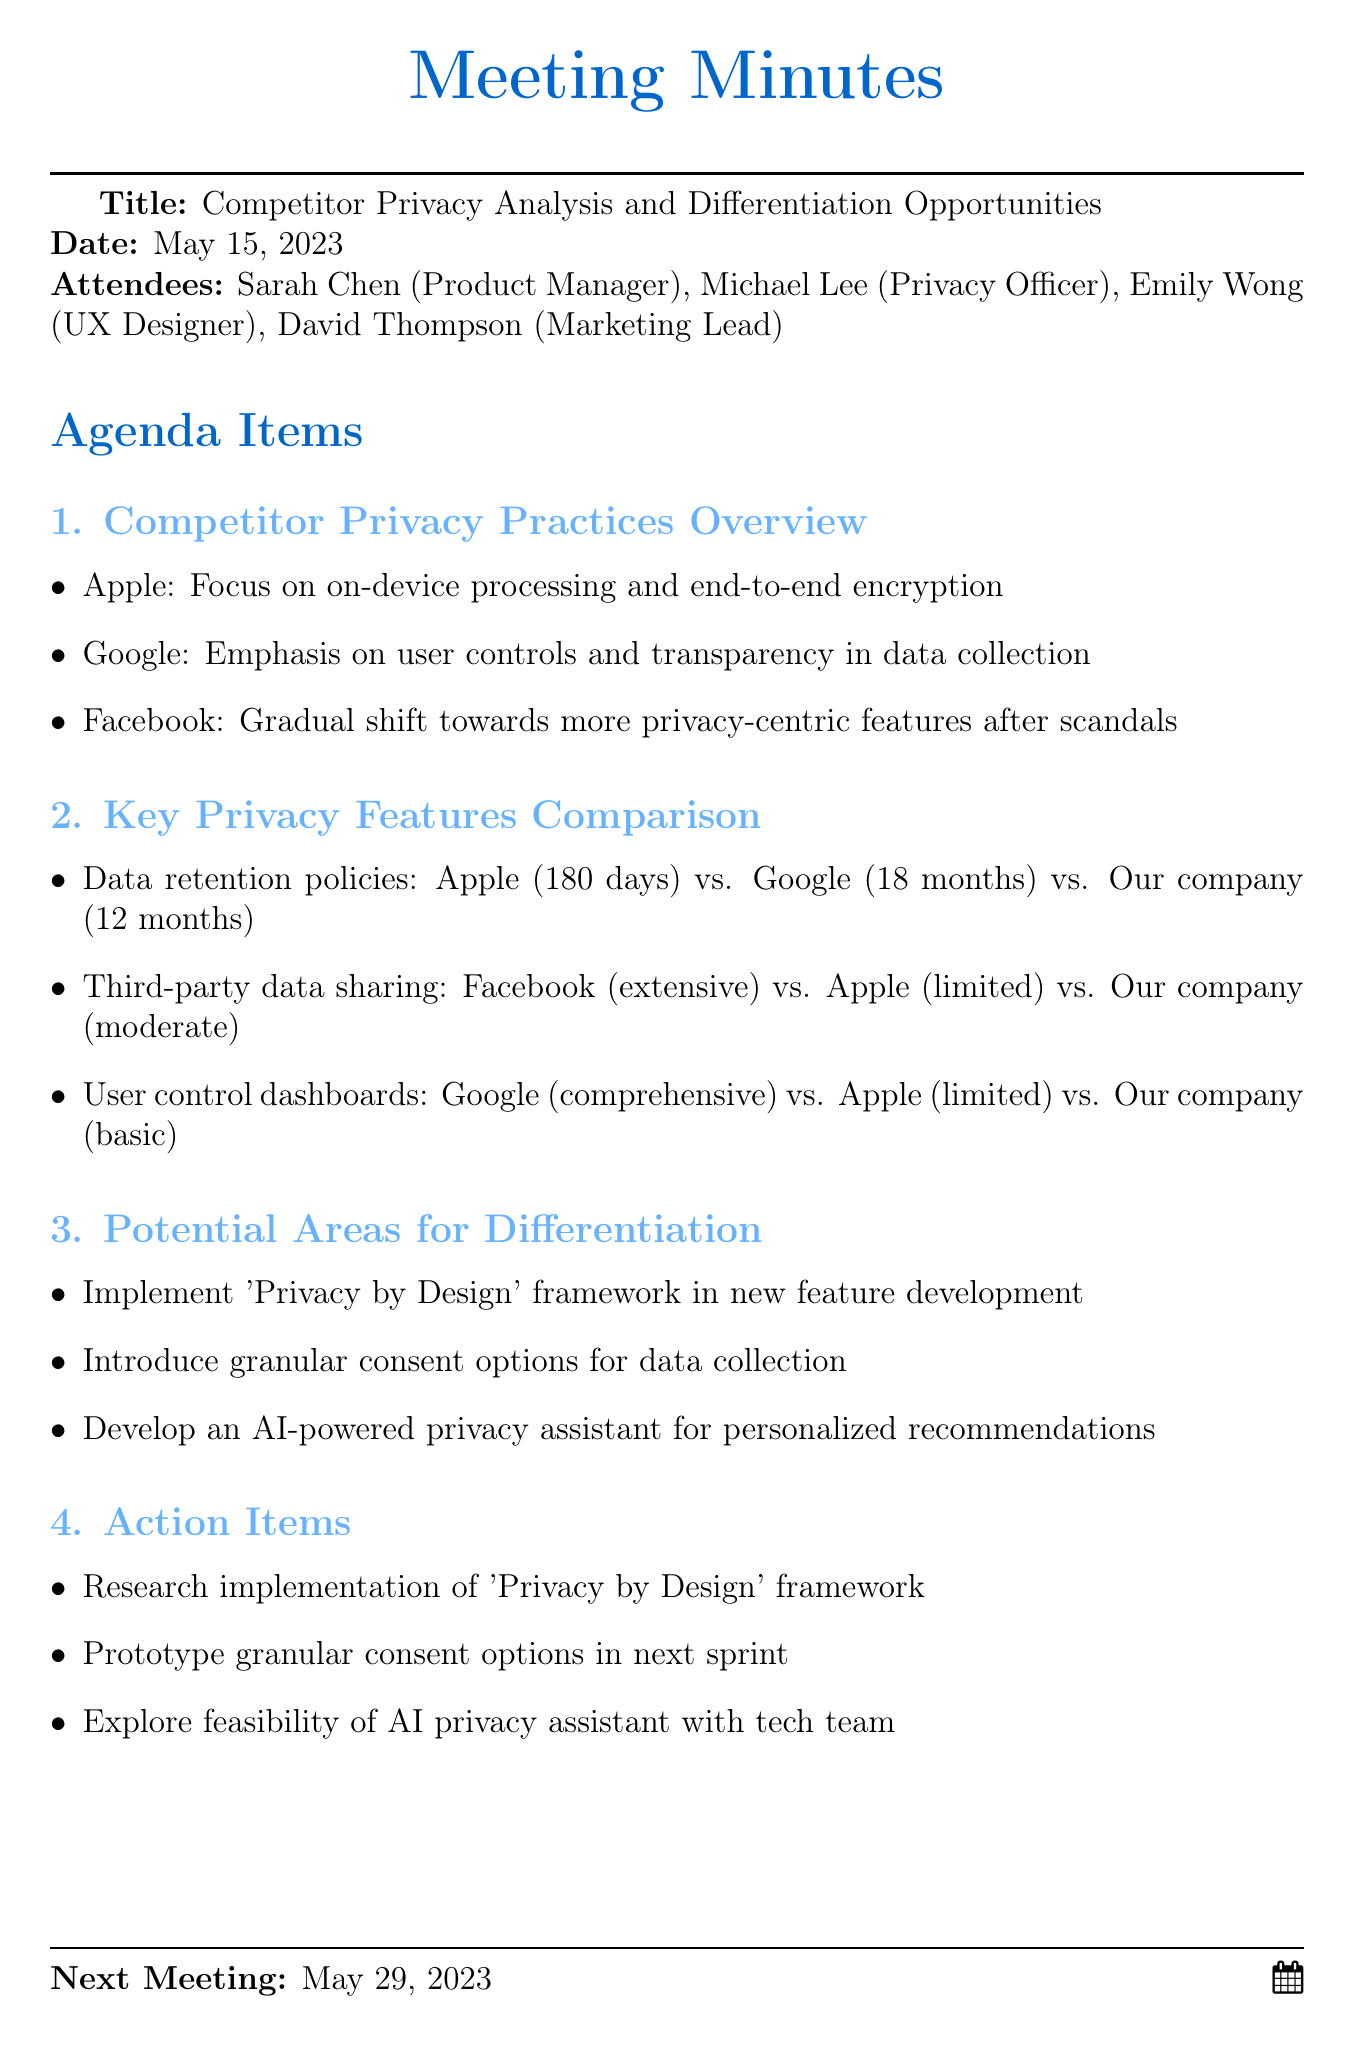What is the meeting date? The meeting took place on May 15, 2023, as stated at the top of the document.
Answer: May 15, 2023 Who is the Privacy Officer? The document specifies that Michael Lee holds the position of Privacy Officer among the attendees.
Answer: Michael Lee What is the data retention policy of our company? The comparison of data retention policies lists our company’s policy as 12 months.
Answer: 12 months What is one of the potential areas for differentiation? The document lists several potential differentiation opportunities, including implementing a 'Privacy by Design' framework.
Answer: 'Privacy by Design' framework How many days is Apple’s data retention policy? In the document, it is stated that Apple has a data retention policy of 180 days.
Answer: 180 days What is the next meeting date? The document concludes with the date of the next meeting scheduled for May 29, 2023.
Answer: May 29, 2023 How many attendees are listed in the document? The document lists four individuals as attendees.
Answer: Four What feature gives users comprehensive control over their data according to Google? The document mentions that Google provides a comprehensive user control dashboard for data management.
Answer: Comprehensive user control dashboard What action item involves the tech team? The document notes that one of the action items is to explore feasibility of an AI privacy assistant with the tech team.
Answer: AI privacy assistant 